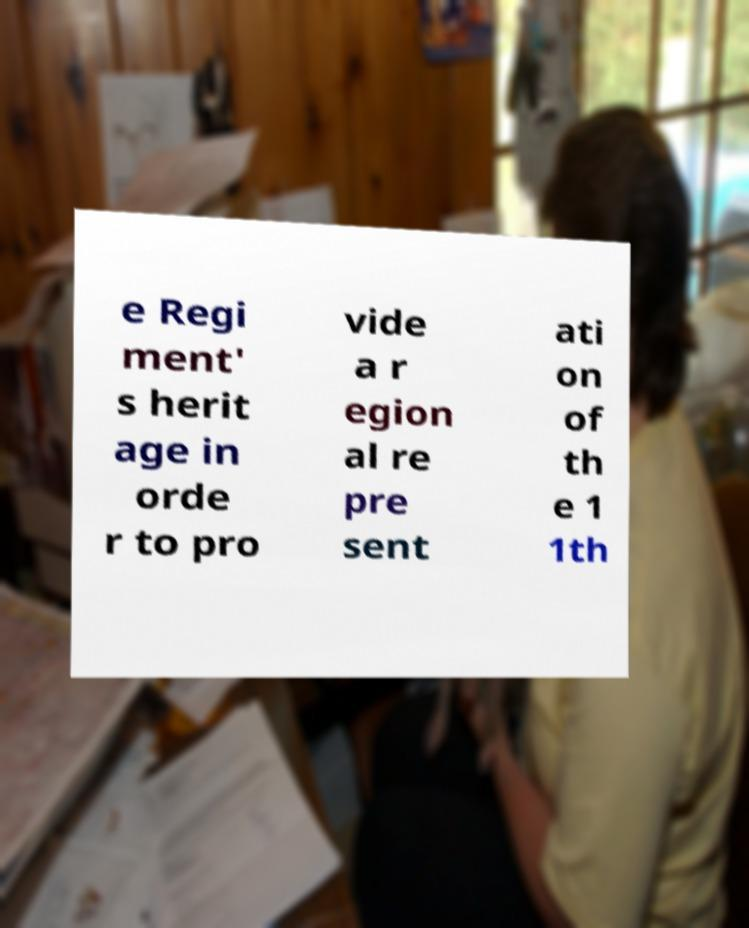What messages or text are displayed in this image? I need them in a readable, typed format. e Regi ment' s herit age in orde r to pro vide a r egion al re pre sent ati on of th e 1 1th 